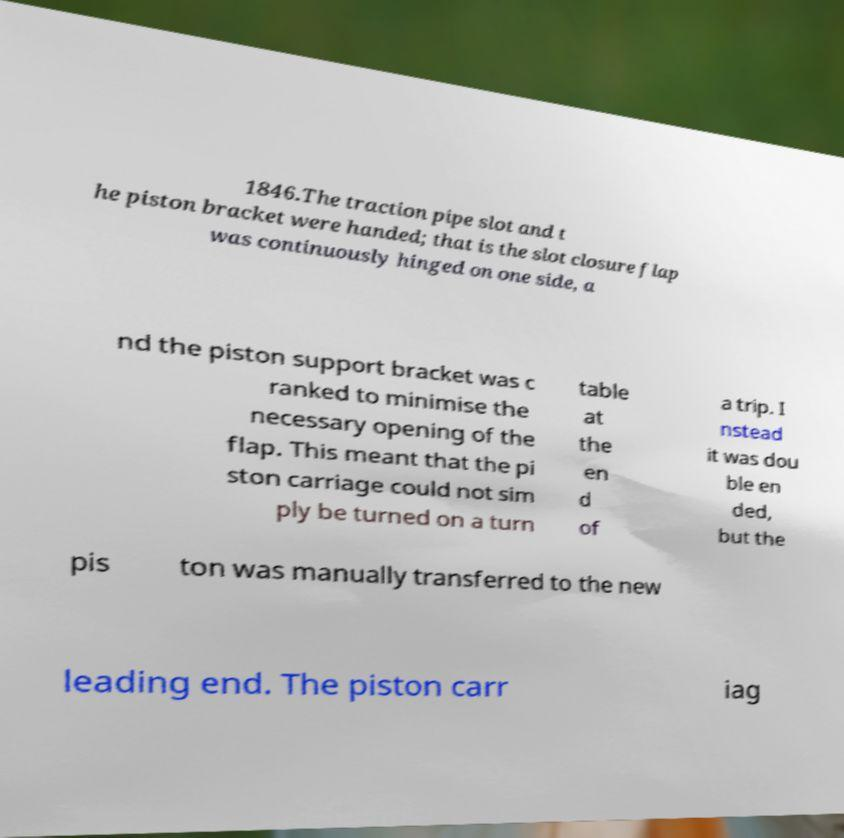Please identify and transcribe the text found in this image. 1846.The traction pipe slot and t he piston bracket were handed; that is the slot closure flap was continuously hinged on one side, a nd the piston support bracket was c ranked to minimise the necessary opening of the flap. This meant that the pi ston carriage could not sim ply be turned on a turn table at the en d of a trip. I nstead it was dou ble en ded, but the pis ton was manually transferred to the new leading end. The piston carr iag 